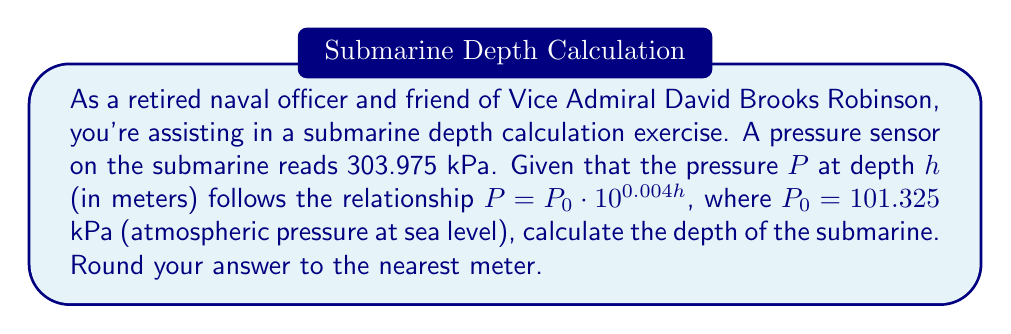Could you help me with this problem? Let's approach this step-by-step:

1) We're given the equation: $P = P_0 \cdot 10^{0.004h}$

2) We know:
   $P = 303.975$ kPa (current pressure)
   $P_0 = 101.325$ kPa (atmospheric pressure at sea level)

3) Let's substitute these values into the equation:

   $303.975 = 101.325 \cdot 10^{0.004h}$

4) To solve for $h$, we need to isolate it. First, divide both sides by 101.325:

   $\frac{303.975}{101.325} = 10^{0.004h}$

5) Simplify:

   $3 = 10^{0.004h}$

6) Now, we can take the logarithm (base 10) of both sides:

   $\log_{10}(3) = \log_{10}(10^{0.004h})$

7) The right side simplifies due to the logarithm rule $\log_a(a^x) = x$:

   $\log_{10}(3) = 0.004h$

8) Now we can solve for $h$:

   $h = \frac{\log_{10}(3)}{0.004}$

9) Calculate:
   
   $h = \frac{0.47712125471966243729502190325}{0.004} \approx 119.28$ meters

10) Rounding to the nearest meter:

    $h \approx 119$ meters
Answer: The submarine is at a depth of approximately 119 meters. 